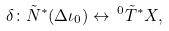<formula> <loc_0><loc_0><loc_500><loc_500>\delta \colon \tilde { N } ^ { * } ( \Delta \iota _ { 0 } ) \leftrightarrow \, ^ { 0 } \tilde { T } ^ { * } X ,</formula> 